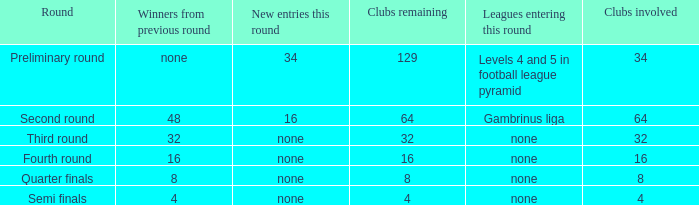Name the new entries this round for third round None. 